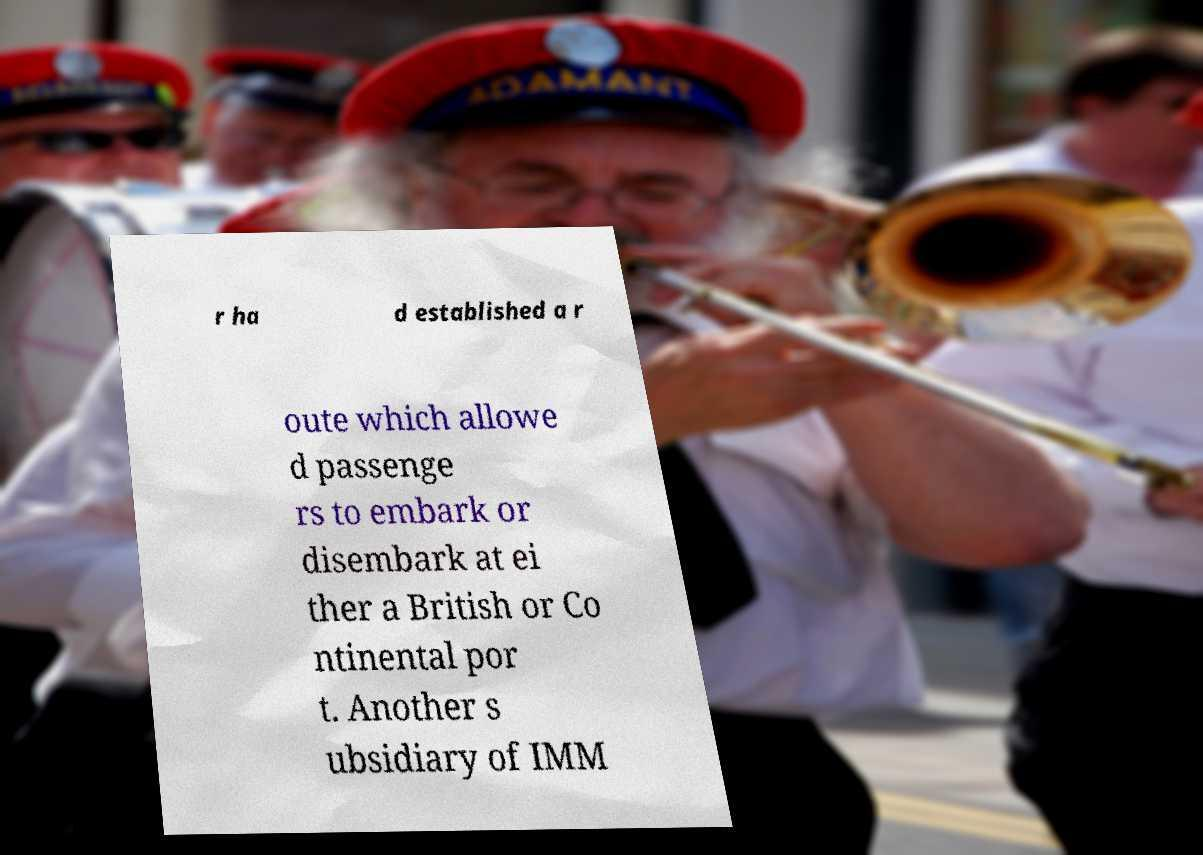For documentation purposes, I need the text within this image transcribed. Could you provide that? r ha d established a r oute which allowe d passenge rs to embark or disembark at ei ther a British or Co ntinental por t. Another s ubsidiary of IMM 